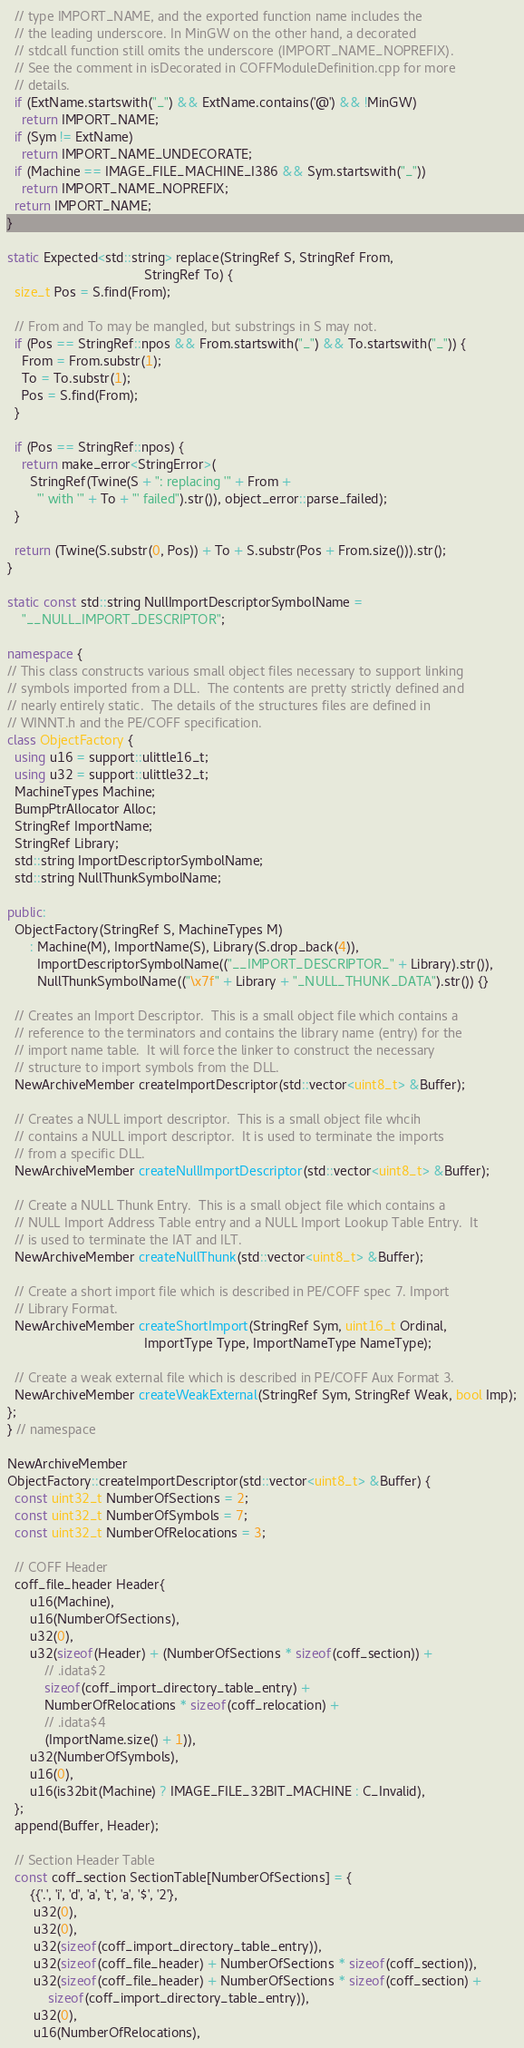<code> <loc_0><loc_0><loc_500><loc_500><_C++_>  // type IMPORT_NAME, and the exported function name includes the
  // the leading underscore. In MinGW on the other hand, a decorated
  // stdcall function still omits the underscore (IMPORT_NAME_NOPREFIX).
  // See the comment in isDecorated in COFFModuleDefinition.cpp for more
  // details.
  if (ExtName.startswith("_") && ExtName.contains('@') && !MinGW)
    return IMPORT_NAME;
  if (Sym != ExtName)
    return IMPORT_NAME_UNDECORATE;
  if (Machine == IMAGE_FILE_MACHINE_I386 && Sym.startswith("_"))
    return IMPORT_NAME_NOPREFIX;
  return IMPORT_NAME;
}

static Expected<std::string> replace(StringRef S, StringRef From,
                                     StringRef To) {
  size_t Pos = S.find(From);

  // From and To may be mangled, but substrings in S may not.
  if (Pos == StringRef::npos && From.startswith("_") && To.startswith("_")) {
    From = From.substr(1);
    To = To.substr(1);
    Pos = S.find(From);
  }

  if (Pos == StringRef::npos) {
    return make_error<StringError>(
      StringRef(Twine(S + ": replacing '" + From +
        "' with '" + To + "' failed").str()), object_error::parse_failed);
  }

  return (Twine(S.substr(0, Pos)) + To + S.substr(Pos + From.size())).str();
}

static const std::string NullImportDescriptorSymbolName =
    "__NULL_IMPORT_DESCRIPTOR";

namespace {
// This class constructs various small object files necessary to support linking
// symbols imported from a DLL.  The contents are pretty strictly defined and
// nearly entirely static.  The details of the structures files are defined in
// WINNT.h and the PE/COFF specification.
class ObjectFactory {
  using u16 = support::ulittle16_t;
  using u32 = support::ulittle32_t;
  MachineTypes Machine;
  BumpPtrAllocator Alloc;
  StringRef ImportName;
  StringRef Library;
  std::string ImportDescriptorSymbolName;
  std::string NullThunkSymbolName;

public:
  ObjectFactory(StringRef S, MachineTypes M)
      : Machine(M), ImportName(S), Library(S.drop_back(4)),
        ImportDescriptorSymbolName(("__IMPORT_DESCRIPTOR_" + Library).str()),
        NullThunkSymbolName(("\x7f" + Library + "_NULL_THUNK_DATA").str()) {}

  // Creates an Import Descriptor.  This is a small object file which contains a
  // reference to the terminators and contains the library name (entry) for the
  // import name table.  It will force the linker to construct the necessary
  // structure to import symbols from the DLL.
  NewArchiveMember createImportDescriptor(std::vector<uint8_t> &Buffer);

  // Creates a NULL import descriptor.  This is a small object file whcih
  // contains a NULL import descriptor.  It is used to terminate the imports
  // from a specific DLL.
  NewArchiveMember createNullImportDescriptor(std::vector<uint8_t> &Buffer);

  // Create a NULL Thunk Entry.  This is a small object file which contains a
  // NULL Import Address Table entry and a NULL Import Lookup Table Entry.  It
  // is used to terminate the IAT and ILT.
  NewArchiveMember createNullThunk(std::vector<uint8_t> &Buffer);

  // Create a short import file which is described in PE/COFF spec 7. Import
  // Library Format.
  NewArchiveMember createShortImport(StringRef Sym, uint16_t Ordinal,
                                     ImportType Type, ImportNameType NameType);

  // Create a weak external file which is described in PE/COFF Aux Format 3.
  NewArchiveMember createWeakExternal(StringRef Sym, StringRef Weak, bool Imp);
};
} // namespace

NewArchiveMember
ObjectFactory::createImportDescriptor(std::vector<uint8_t> &Buffer) {
  const uint32_t NumberOfSections = 2;
  const uint32_t NumberOfSymbols = 7;
  const uint32_t NumberOfRelocations = 3;

  // COFF Header
  coff_file_header Header{
      u16(Machine),
      u16(NumberOfSections),
      u32(0),
      u32(sizeof(Header) + (NumberOfSections * sizeof(coff_section)) +
          // .idata$2
          sizeof(coff_import_directory_table_entry) +
          NumberOfRelocations * sizeof(coff_relocation) +
          // .idata$4
          (ImportName.size() + 1)),
      u32(NumberOfSymbols),
      u16(0),
      u16(is32bit(Machine) ? IMAGE_FILE_32BIT_MACHINE : C_Invalid),
  };
  append(Buffer, Header);

  // Section Header Table
  const coff_section SectionTable[NumberOfSections] = {
      {{'.', 'i', 'd', 'a', 't', 'a', '$', '2'},
       u32(0),
       u32(0),
       u32(sizeof(coff_import_directory_table_entry)),
       u32(sizeof(coff_file_header) + NumberOfSections * sizeof(coff_section)),
       u32(sizeof(coff_file_header) + NumberOfSections * sizeof(coff_section) +
           sizeof(coff_import_directory_table_entry)),
       u32(0),
       u16(NumberOfRelocations),</code> 